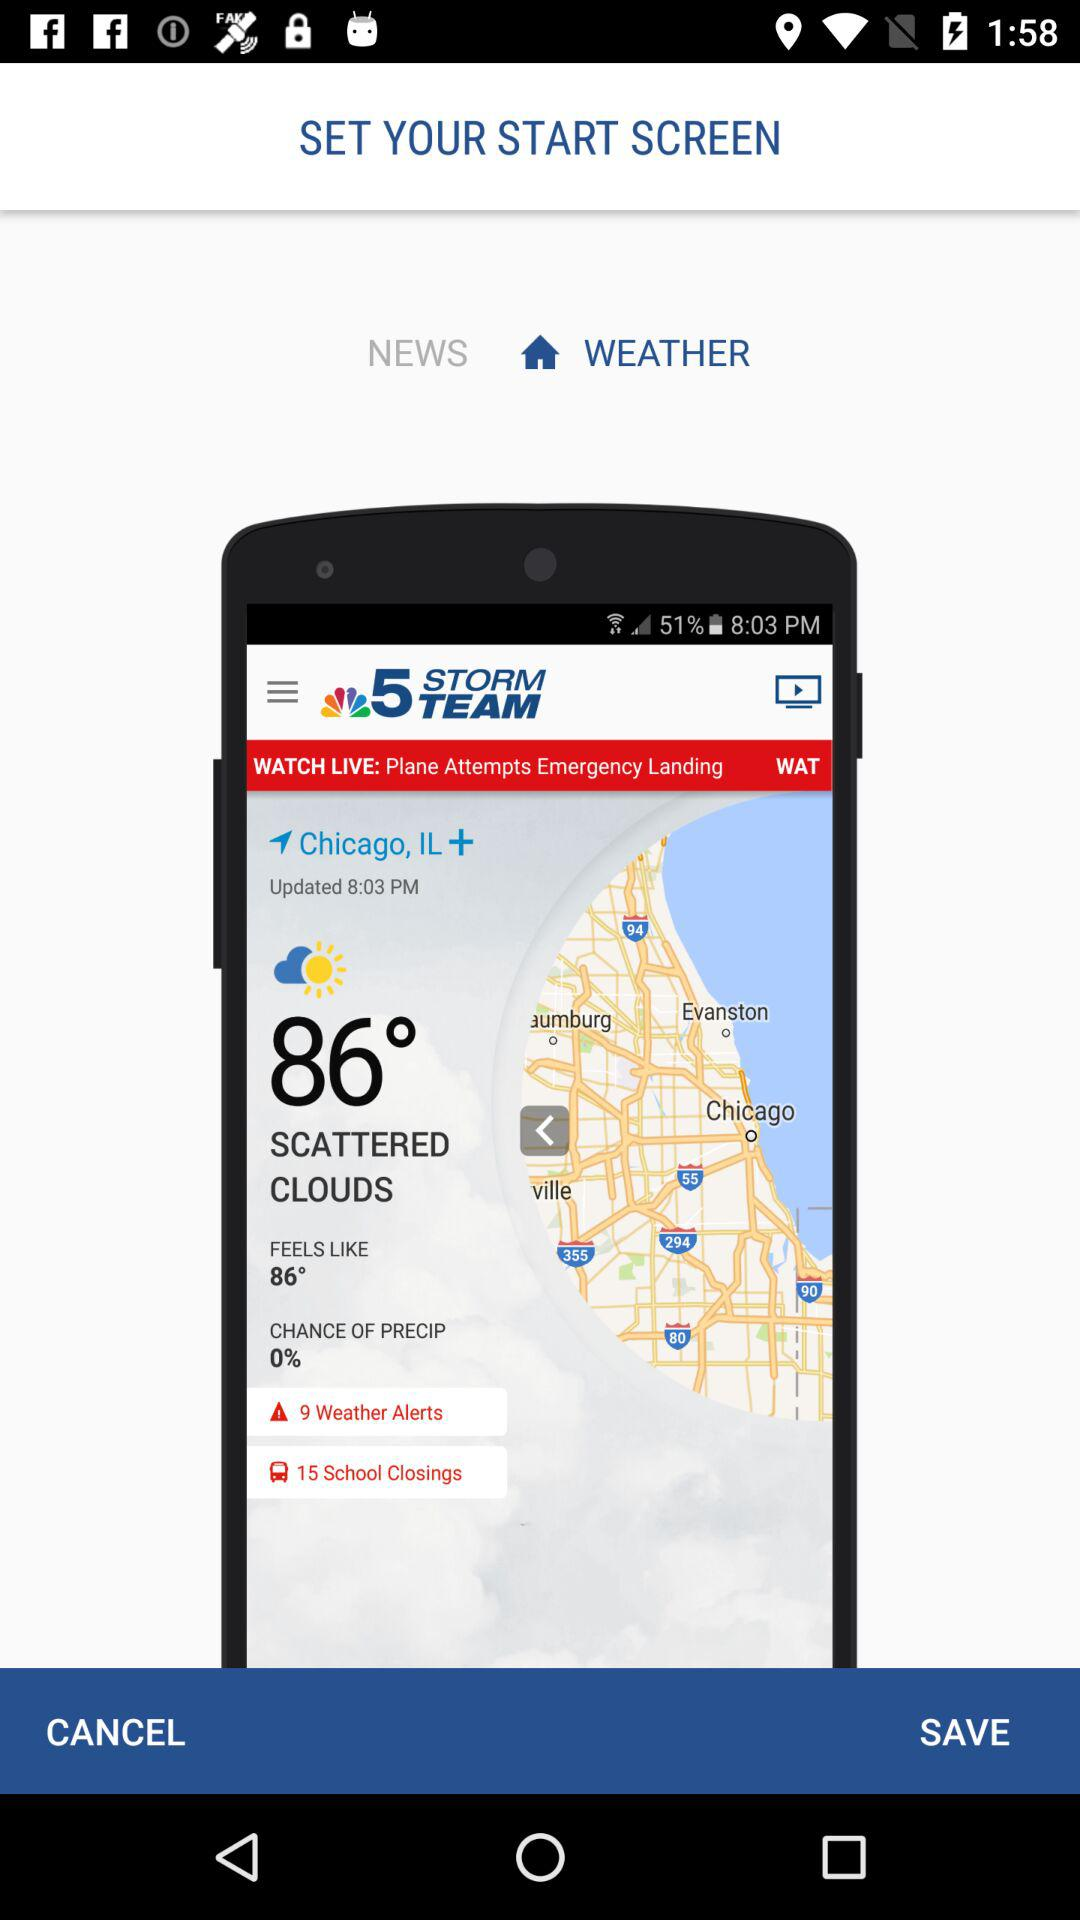What is the updated time? The updated time is 8:03 p.m. 